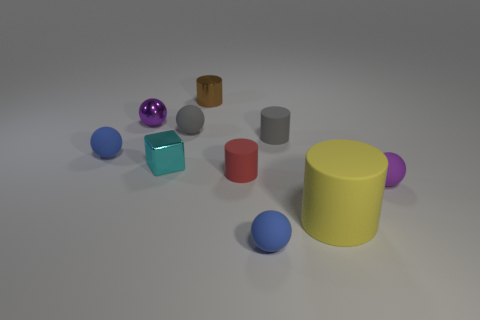Subtract all cylinders. How many objects are left? 6 Subtract all brown cylinders. How many cylinders are left? 3 Subtract all small cylinders. How many cylinders are left? 1 Subtract 3 balls. How many balls are left? 2 Subtract all yellow balls. Subtract all red blocks. How many balls are left? 5 Subtract all cyan balls. How many blue blocks are left? 0 Subtract all purple rubber balls. Subtract all tiny blocks. How many objects are left? 8 Add 7 small brown metal objects. How many small brown metal objects are left? 8 Add 8 tiny red matte cylinders. How many tiny red matte cylinders exist? 9 Subtract 1 brown cylinders. How many objects are left? 9 